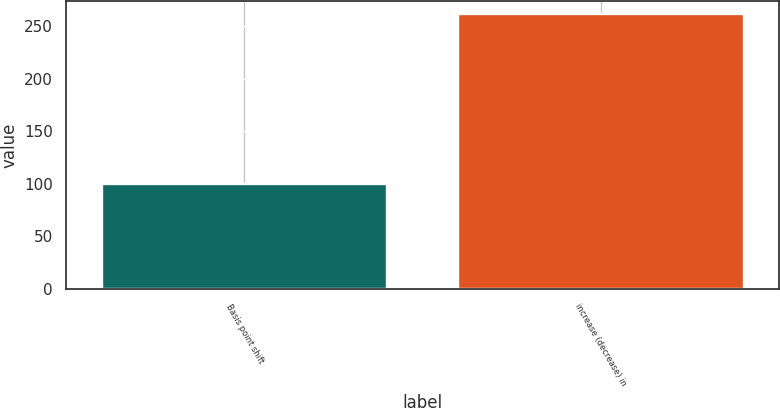Convert chart. <chart><loc_0><loc_0><loc_500><loc_500><bar_chart><fcel>Basis point shift<fcel>increase (decrease) in<nl><fcel>100<fcel>261<nl></chart> 